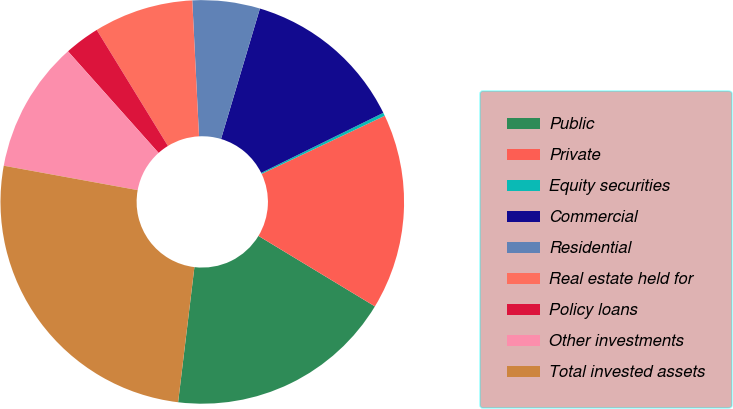<chart> <loc_0><loc_0><loc_500><loc_500><pie_chart><fcel>Public<fcel>Private<fcel>Equity securities<fcel>Commercial<fcel>Residential<fcel>Real estate held for<fcel>Policy loans<fcel>Other investments<fcel>Total invested assets<nl><fcel>18.25%<fcel>15.68%<fcel>0.26%<fcel>13.11%<fcel>5.4%<fcel>7.97%<fcel>2.83%<fcel>10.54%<fcel>25.96%<nl></chart> 